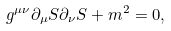<formula> <loc_0><loc_0><loc_500><loc_500>g ^ { \mu \nu } \partial _ { \mu } S \partial _ { \nu } S + m ^ { 2 } = 0 ,</formula> 